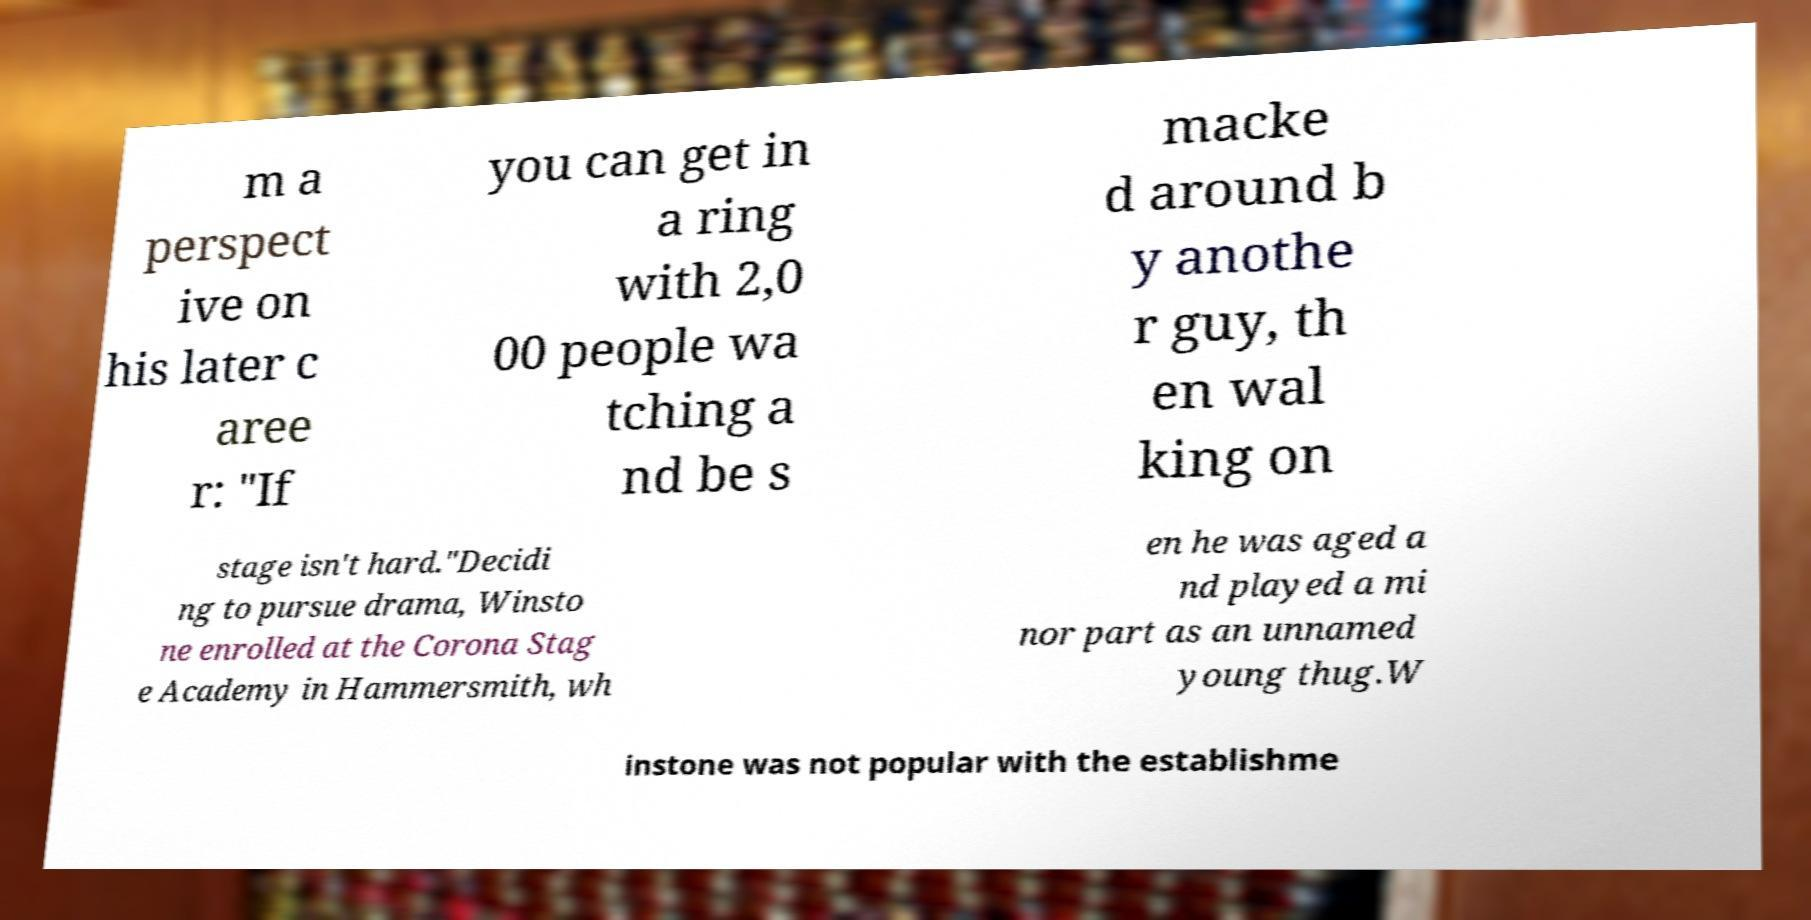There's text embedded in this image that I need extracted. Can you transcribe it verbatim? m a perspect ive on his later c aree r: "If you can get in a ring with 2,0 00 people wa tching a nd be s macke d around b y anothe r guy, th en wal king on stage isn't hard."Decidi ng to pursue drama, Winsto ne enrolled at the Corona Stag e Academy in Hammersmith, wh en he was aged a nd played a mi nor part as an unnamed young thug.W instone was not popular with the establishme 